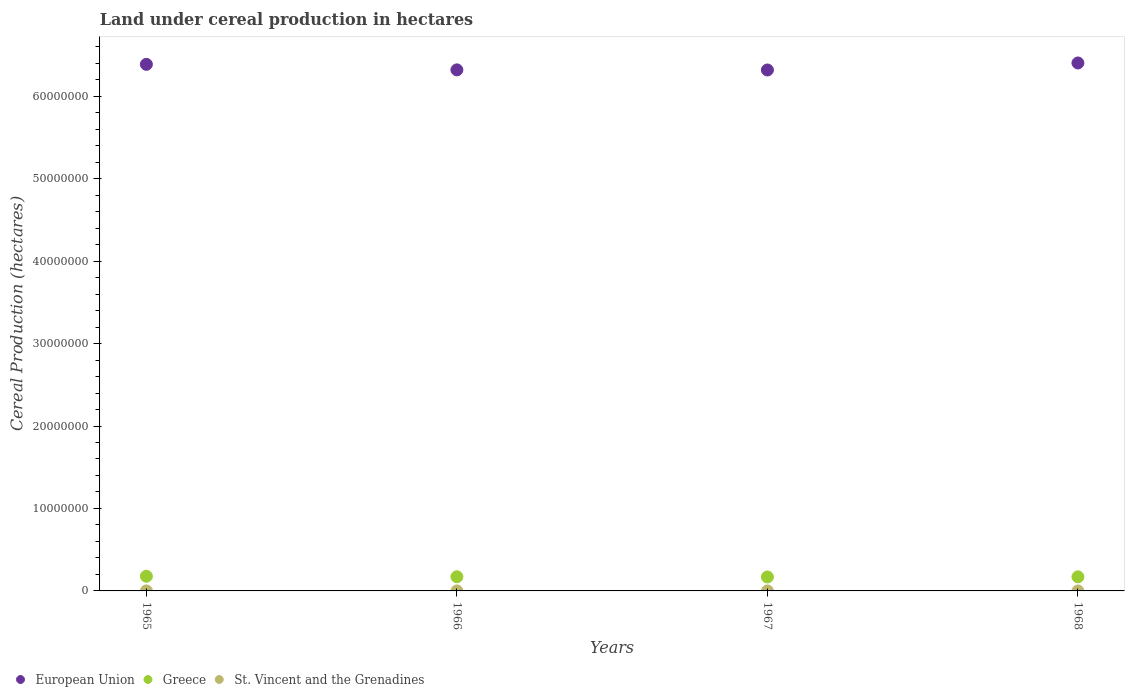What is the land under cereal production in St. Vincent and the Grenadines in 1967?
Give a very brief answer. 125. Across all years, what is the maximum land under cereal production in Greece?
Give a very brief answer. 1.78e+06. Across all years, what is the minimum land under cereal production in St. Vincent and the Grenadines?
Provide a short and direct response. 100. In which year was the land under cereal production in European Union maximum?
Your answer should be very brief. 1968. In which year was the land under cereal production in European Union minimum?
Give a very brief answer. 1967. What is the total land under cereal production in St. Vincent and the Grenadines in the graph?
Give a very brief answer. 470. What is the difference between the land under cereal production in Greece in 1967 and that in 1968?
Make the answer very short. -1.78e+04. What is the difference between the land under cereal production in St. Vincent and the Grenadines in 1967 and the land under cereal production in European Union in 1965?
Your response must be concise. -6.39e+07. What is the average land under cereal production in European Union per year?
Give a very brief answer. 6.36e+07. In the year 1966, what is the difference between the land under cereal production in Greece and land under cereal production in St. Vincent and the Grenadines?
Give a very brief answer. 1.72e+06. In how many years, is the land under cereal production in Greece greater than 36000000 hectares?
Keep it short and to the point. 0. What is the ratio of the land under cereal production in Greece in 1967 to that in 1968?
Provide a succinct answer. 0.99. Is the land under cereal production in Greece in 1966 less than that in 1968?
Make the answer very short. No. Is the difference between the land under cereal production in Greece in 1966 and 1968 greater than the difference between the land under cereal production in St. Vincent and the Grenadines in 1966 and 1968?
Provide a short and direct response. Yes. What is the difference between the highest and the lowest land under cereal production in Greece?
Offer a very short reply. 8.89e+04. In how many years, is the land under cereal production in European Union greater than the average land under cereal production in European Union taken over all years?
Make the answer very short. 2. Does the land under cereal production in European Union monotonically increase over the years?
Your answer should be compact. No. Is the land under cereal production in St. Vincent and the Grenadines strictly less than the land under cereal production in European Union over the years?
Make the answer very short. Yes. Are the values on the major ticks of Y-axis written in scientific E-notation?
Your answer should be very brief. No. Does the graph contain grids?
Offer a terse response. No. Where does the legend appear in the graph?
Keep it short and to the point. Bottom left. How are the legend labels stacked?
Your answer should be very brief. Horizontal. What is the title of the graph?
Give a very brief answer. Land under cereal production in hectares. Does "Tanzania" appear as one of the legend labels in the graph?
Make the answer very short. No. What is the label or title of the Y-axis?
Keep it short and to the point. Cereal Production (hectares). What is the Cereal Production (hectares) of European Union in 1965?
Your answer should be very brief. 6.39e+07. What is the Cereal Production (hectares) in Greece in 1965?
Make the answer very short. 1.78e+06. What is the Cereal Production (hectares) in European Union in 1966?
Give a very brief answer. 6.32e+07. What is the Cereal Production (hectares) in Greece in 1966?
Give a very brief answer. 1.72e+06. What is the Cereal Production (hectares) in St. Vincent and the Grenadines in 1966?
Provide a short and direct response. 120. What is the Cereal Production (hectares) in European Union in 1967?
Make the answer very short. 6.32e+07. What is the Cereal Production (hectares) of Greece in 1967?
Your response must be concise. 1.69e+06. What is the Cereal Production (hectares) in St. Vincent and the Grenadines in 1967?
Ensure brevity in your answer.  125. What is the Cereal Production (hectares) in European Union in 1968?
Provide a succinct answer. 6.40e+07. What is the Cereal Production (hectares) of Greece in 1968?
Your answer should be compact. 1.71e+06. What is the Cereal Production (hectares) in St. Vincent and the Grenadines in 1968?
Your answer should be very brief. 125. Across all years, what is the maximum Cereal Production (hectares) of European Union?
Make the answer very short. 6.40e+07. Across all years, what is the maximum Cereal Production (hectares) in Greece?
Your answer should be compact. 1.78e+06. Across all years, what is the maximum Cereal Production (hectares) in St. Vincent and the Grenadines?
Your answer should be very brief. 125. Across all years, what is the minimum Cereal Production (hectares) of European Union?
Give a very brief answer. 6.32e+07. Across all years, what is the minimum Cereal Production (hectares) in Greece?
Keep it short and to the point. 1.69e+06. What is the total Cereal Production (hectares) of European Union in the graph?
Give a very brief answer. 2.54e+08. What is the total Cereal Production (hectares) in Greece in the graph?
Your response must be concise. 6.90e+06. What is the total Cereal Production (hectares) of St. Vincent and the Grenadines in the graph?
Your response must be concise. 470. What is the difference between the Cereal Production (hectares) of European Union in 1965 and that in 1966?
Your response must be concise. 6.71e+05. What is the difference between the Cereal Production (hectares) in Greece in 1965 and that in 1966?
Provide a short and direct response. 6.25e+04. What is the difference between the Cereal Production (hectares) of St. Vincent and the Grenadines in 1965 and that in 1966?
Offer a terse response. -20. What is the difference between the Cereal Production (hectares) of European Union in 1965 and that in 1967?
Provide a succinct answer. 6.87e+05. What is the difference between the Cereal Production (hectares) of Greece in 1965 and that in 1967?
Provide a short and direct response. 8.89e+04. What is the difference between the Cereal Production (hectares) of St. Vincent and the Grenadines in 1965 and that in 1967?
Your response must be concise. -25. What is the difference between the Cereal Production (hectares) of European Union in 1965 and that in 1968?
Your answer should be compact. -1.64e+05. What is the difference between the Cereal Production (hectares) in Greece in 1965 and that in 1968?
Your answer should be compact. 7.11e+04. What is the difference between the Cereal Production (hectares) in European Union in 1966 and that in 1967?
Offer a very short reply. 1.53e+04. What is the difference between the Cereal Production (hectares) of Greece in 1966 and that in 1967?
Provide a short and direct response. 2.64e+04. What is the difference between the Cereal Production (hectares) of St. Vincent and the Grenadines in 1966 and that in 1967?
Make the answer very short. -5. What is the difference between the Cereal Production (hectares) of European Union in 1966 and that in 1968?
Provide a succinct answer. -8.36e+05. What is the difference between the Cereal Production (hectares) of Greece in 1966 and that in 1968?
Provide a short and direct response. 8560. What is the difference between the Cereal Production (hectares) of St. Vincent and the Grenadines in 1966 and that in 1968?
Give a very brief answer. -5. What is the difference between the Cereal Production (hectares) of European Union in 1967 and that in 1968?
Provide a succinct answer. -8.51e+05. What is the difference between the Cereal Production (hectares) in Greece in 1967 and that in 1968?
Your answer should be very brief. -1.78e+04. What is the difference between the Cereal Production (hectares) in St. Vincent and the Grenadines in 1967 and that in 1968?
Provide a succinct answer. 0. What is the difference between the Cereal Production (hectares) of European Union in 1965 and the Cereal Production (hectares) of Greece in 1966?
Offer a terse response. 6.22e+07. What is the difference between the Cereal Production (hectares) in European Union in 1965 and the Cereal Production (hectares) in St. Vincent and the Grenadines in 1966?
Keep it short and to the point. 6.39e+07. What is the difference between the Cereal Production (hectares) in Greece in 1965 and the Cereal Production (hectares) in St. Vincent and the Grenadines in 1966?
Provide a short and direct response. 1.78e+06. What is the difference between the Cereal Production (hectares) of European Union in 1965 and the Cereal Production (hectares) of Greece in 1967?
Offer a very short reply. 6.22e+07. What is the difference between the Cereal Production (hectares) in European Union in 1965 and the Cereal Production (hectares) in St. Vincent and the Grenadines in 1967?
Your answer should be compact. 6.39e+07. What is the difference between the Cereal Production (hectares) in Greece in 1965 and the Cereal Production (hectares) in St. Vincent and the Grenadines in 1967?
Give a very brief answer. 1.78e+06. What is the difference between the Cereal Production (hectares) of European Union in 1965 and the Cereal Production (hectares) of Greece in 1968?
Offer a very short reply. 6.22e+07. What is the difference between the Cereal Production (hectares) of European Union in 1965 and the Cereal Production (hectares) of St. Vincent and the Grenadines in 1968?
Provide a short and direct response. 6.39e+07. What is the difference between the Cereal Production (hectares) in Greece in 1965 and the Cereal Production (hectares) in St. Vincent and the Grenadines in 1968?
Your response must be concise. 1.78e+06. What is the difference between the Cereal Production (hectares) in European Union in 1966 and the Cereal Production (hectares) in Greece in 1967?
Offer a very short reply. 6.15e+07. What is the difference between the Cereal Production (hectares) of European Union in 1966 and the Cereal Production (hectares) of St. Vincent and the Grenadines in 1967?
Offer a terse response. 6.32e+07. What is the difference between the Cereal Production (hectares) in Greece in 1966 and the Cereal Production (hectares) in St. Vincent and the Grenadines in 1967?
Ensure brevity in your answer.  1.72e+06. What is the difference between the Cereal Production (hectares) in European Union in 1966 and the Cereal Production (hectares) in Greece in 1968?
Keep it short and to the point. 6.15e+07. What is the difference between the Cereal Production (hectares) in European Union in 1966 and the Cereal Production (hectares) in St. Vincent and the Grenadines in 1968?
Provide a short and direct response. 6.32e+07. What is the difference between the Cereal Production (hectares) in Greece in 1966 and the Cereal Production (hectares) in St. Vincent and the Grenadines in 1968?
Ensure brevity in your answer.  1.72e+06. What is the difference between the Cereal Production (hectares) in European Union in 1967 and the Cereal Production (hectares) in Greece in 1968?
Provide a succinct answer. 6.15e+07. What is the difference between the Cereal Production (hectares) in European Union in 1967 and the Cereal Production (hectares) in St. Vincent and the Grenadines in 1968?
Provide a short and direct response. 6.32e+07. What is the difference between the Cereal Production (hectares) in Greece in 1967 and the Cereal Production (hectares) in St. Vincent and the Grenadines in 1968?
Give a very brief answer. 1.69e+06. What is the average Cereal Production (hectares) in European Union per year?
Provide a short and direct response. 6.36e+07. What is the average Cereal Production (hectares) in Greece per year?
Give a very brief answer. 1.72e+06. What is the average Cereal Production (hectares) in St. Vincent and the Grenadines per year?
Your response must be concise. 117.5. In the year 1965, what is the difference between the Cereal Production (hectares) of European Union and Cereal Production (hectares) of Greece?
Your answer should be very brief. 6.21e+07. In the year 1965, what is the difference between the Cereal Production (hectares) of European Union and Cereal Production (hectares) of St. Vincent and the Grenadines?
Provide a succinct answer. 6.39e+07. In the year 1965, what is the difference between the Cereal Production (hectares) in Greece and Cereal Production (hectares) in St. Vincent and the Grenadines?
Give a very brief answer. 1.78e+06. In the year 1966, what is the difference between the Cereal Production (hectares) in European Union and Cereal Production (hectares) in Greece?
Keep it short and to the point. 6.15e+07. In the year 1966, what is the difference between the Cereal Production (hectares) of European Union and Cereal Production (hectares) of St. Vincent and the Grenadines?
Offer a terse response. 6.32e+07. In the year 1966, what is the difference between the Cereal Production (hectares) in Greece and Cereal Production (hectares) in St. Vincent and the Grenadines?
Your response must be concise. 1.72e+06. In the year 1967, what is the difference between the Cereal Production (hectares) in European Union and Cereal Production (hectares) in Greece?
Make the answer very short. 6.15e+07. In the year 1967, what is the difference between the Cereal Production (hectares) of European Union and Cereal Production (hectares) of St. Vincent and the Grenadines?
Your response must be concise. 6.32e+07. In the year 1967, what is the difference between the Cereal Production (hectares) in Greece and Cereal Production (hectares) in St. Vincent and the Grenadines?
Give a very brief answer. 1.69e+06. In the year 1968, what is the difference between the Cereal Production (hectares) of European Union and Cereal Production (hectares) of Greece?
Your answer should be compact. 6.23e+07. In the year 1968, what is the difference between the Cereal Production (hectares) in European Union and Cereal Production (hectares) in St. Vincent and the Grenadines?
Your answer should be compact. 6.40e+07. In the year 1968, what is the difference between the Cereal Production (hectares) in Greece and Cereal Production (hectares) in St. Vincent and the Grenadines?
Ensure brevity in your answer.  1.71e+06. What is the ratio of the Cereal Production (hectares) of European Union in 1965 to that in 1966?
Offer a very short reply. 1.01. What is the ratio of the Cereal Production (hectares) of Greece in 1965 to that in 1966?
Your answer should be compact. 1.04. What is the ratio of the Cereal Production (hectares) of St. Vincent and the Grenadines in 1965 to that in 1966?
Give a very brief answer. 0.83. What is the ratio of the Cereal Production (hectares) in European Union in 1965 to that in 1967?
Your answer should be compact. 1.01. What is the ratio of the Cereal Production (hectares) in Greece in 1965 to that in 1967?
Provide a short and direct response. 1.05. What is the ratio of the Cereal Production (hectares) of St. Vincent and the Grenadines in 1965 to that in 1967?
Your response must be concise. 0.8. What is the ratio of the Cereal Production (hectares) of Greece in 1965 to that in 1968?
Provide a short and direct response. 1.04. What is the ratio of the Cereal Production (hectares) of St. Vincent and the Grenadines in 1965 to that in 1968?
Offer a very short reply. 0.8. What is the ratio of the Cereal Production (hectares) in Greece in 1966 to that in 1967?
Ensure brevity in your answer.  1.02. What is the ratio of the Cereal Production (hectares) of St. Vincent and the Grenadines in 1966 to that in 1967?
Make the answer very short. 0.96. What is the ratio of the Cereal Production (hectares) in European Union in 1966 to that in 1968?
Offer a terse response. 0.99. What is the ratio of the Cereal Production (hectares) of Greece in 1966 to that in 1968?
Offer a terse response. 1. What is the ratio of the Cereal Production (hectares) in European Union in 1967 to that in 1968?
Provide a succinct answer. 0.99. What is the ratio of the Cereal Production (hectares) of St. Vincent and the Grenadines in 1967 to that in 1968?
Your answer should be very brief. 1. What is the difference between the highest and the second highest Cereal Production (hectares) of European Union?
Give a very brief answer. 1.64e+05. What is the difference between the highest and the second highest Cereal Production (hectares) in Greece?
Your answer should be very brief. 6.25e+04. What is the difference between the highest and the second highest Cereal Production (hectares) in St. Vincent and the Grenadines?
Ensure brevity in your answer.  0. What is the difference between the highest and the lowest Cereal Production (hectares) of European Union?
Ensure brevity in your answer.  8.51e+05. What is the difference between the highest and the lowest Cereal Production (hectares) in Greece?
Make the answer very short. 8.89e+04. 